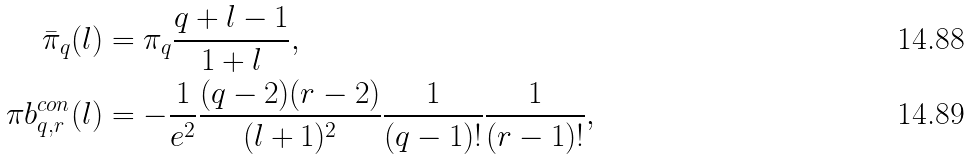Convert formula to latex. <formula><loc_0><loc_0><loc_500><loc_500>\bar { \pi } _ { q } ( l ) & = \pi _ { q } \frac { q + l - 1 } { 1 + l } , \\ \pi b ^ { c o n } _ { q , r } ( l ) & = - \frac { 1 } { e ^ { 2 } } \frac { ( q - 2 ) ( r - 2 ) } { ( l + 1 ) ^ { 2 } } \frac { 1 } { ( q - 1 ) ! } \frac { 1 } { ( r - 1 ) ! } ,</formula> 